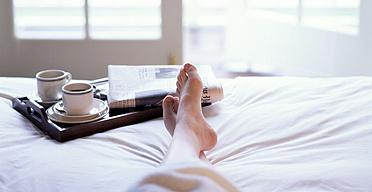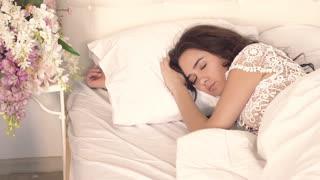The first image is the image on the left, the second image is the image on the right. Examine the images to the left and right. Is the description "In one image a woman is sitting on a bed with her legs crossed and holding a beverage in a white cup." accurate? Answer yes or no. No. The first image is the image on the left, the second image is the image on the right. Analyze the images presented: Is the assertion "The left image contains a human sitting on a bed holding a coffee cup." valid? Answer yes or no. No. 